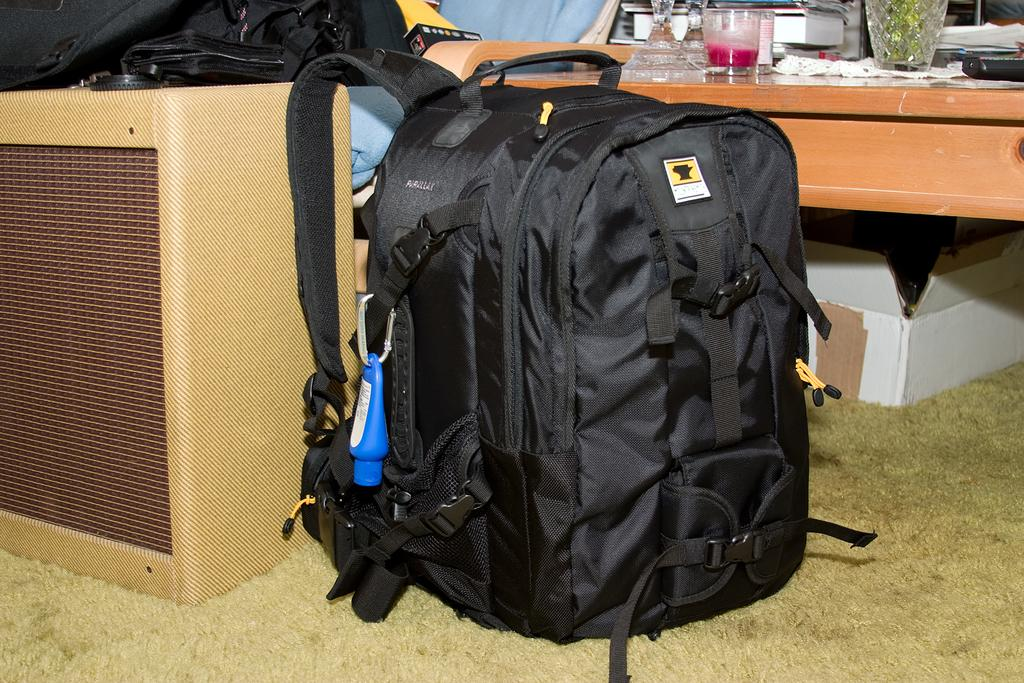What is on the ground in the image? There is a bag on the ground in the image. What piece of furniture is present in the image? There is a table in the image. What is on the table? There is a glass on the table, and there is a book on the table as well. What is inside the glass? There is liquid in the glass. Can you see any baseball players in the image? There are no baseball players present in the image. Are there any fairies flying around the table in the image? There are no fairies present in the image. 